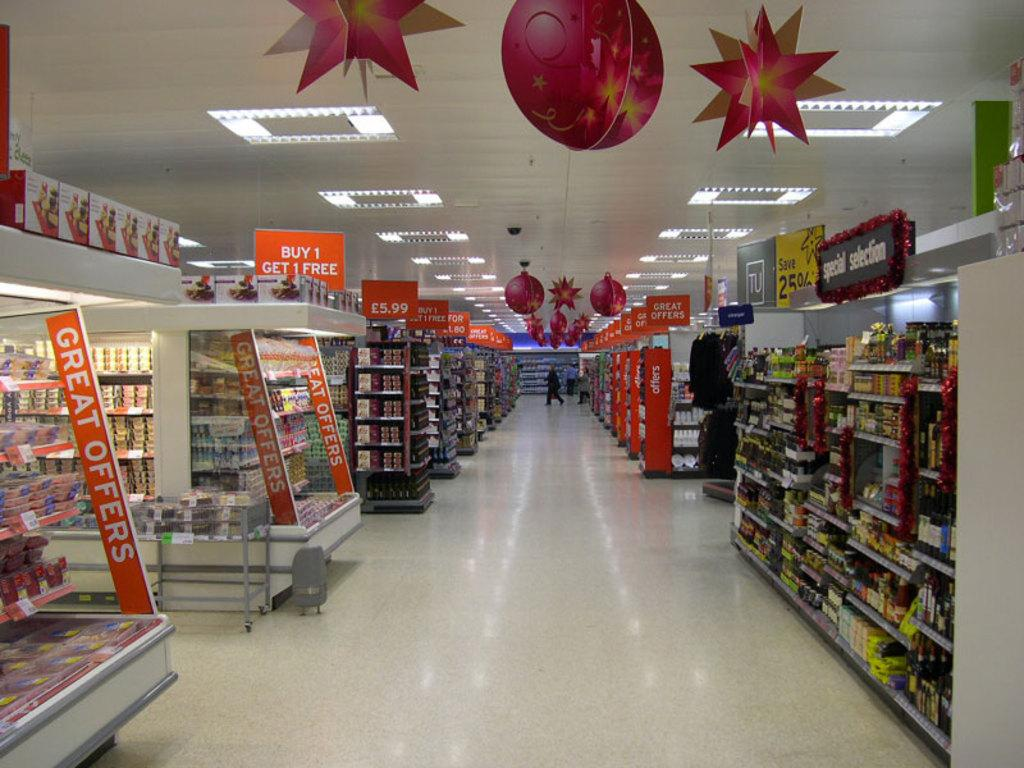<image>
Relay a brief, clear account of the picture shown. A photo inside a store that has an orange banner that reads Buy 1 get 1 free. 